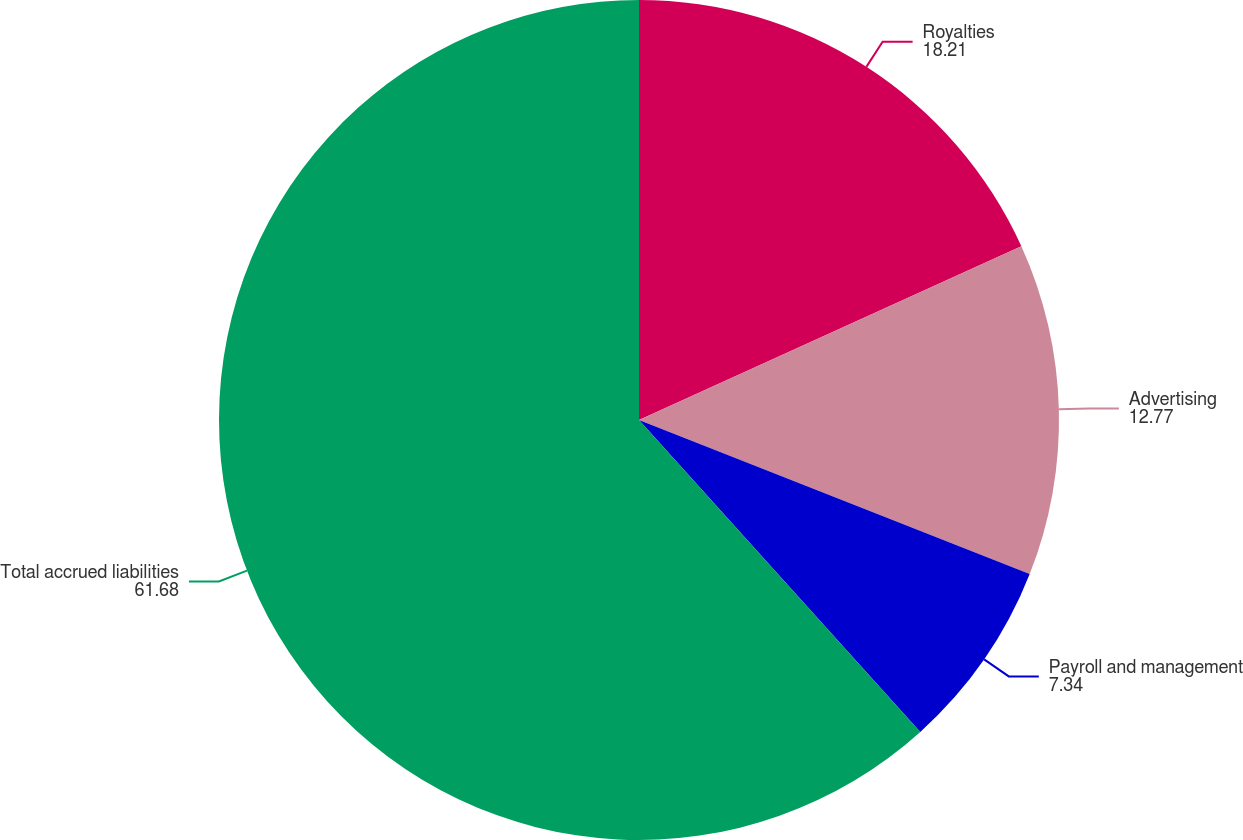Convert chart. <chart><loc_0><loc_0><loc_500><loc_500><pie_chart><fcel>Royalties<fcel>Advertising<fcel>Payroll and management<fcel>Total accrued liabilities<nl><fcel>18.21%<fcel>12.77%<fcel>7.34%<fcel>61.68%<nl></chart> 